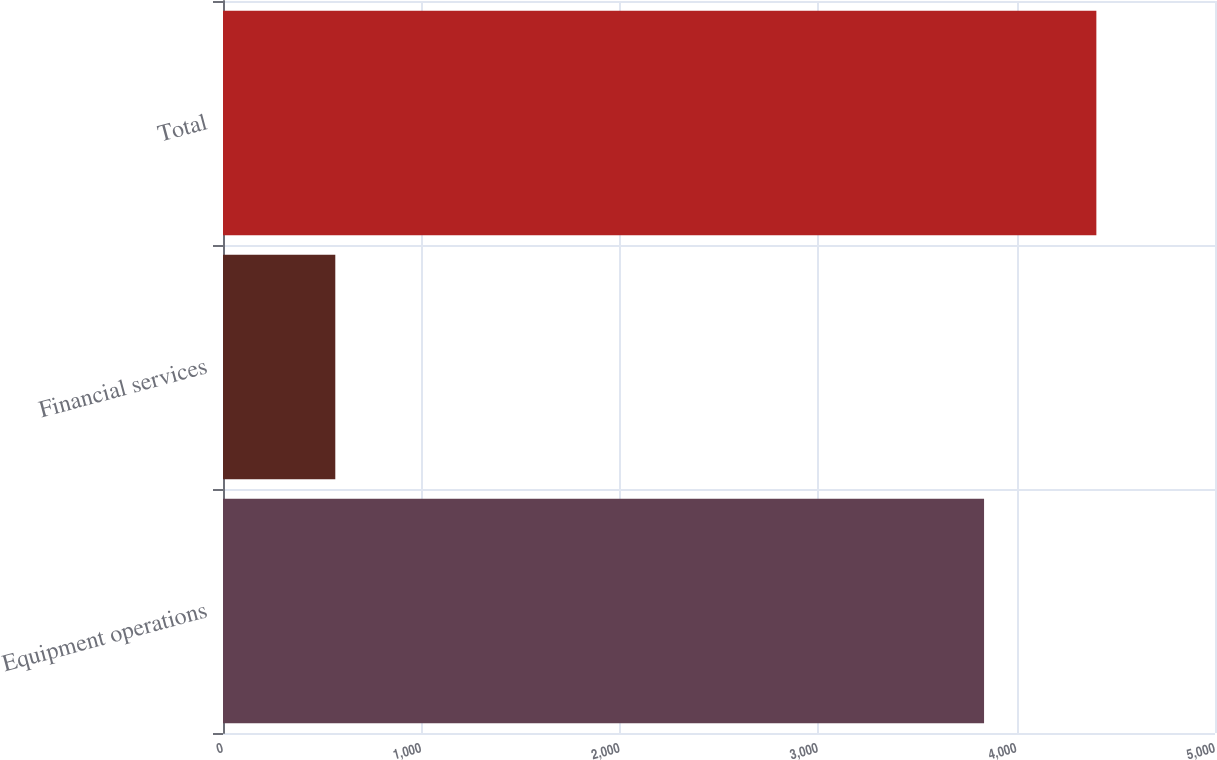Convert chart. <chart><loc_0><loc_0><loc_500><loc_500><bar_chart><fcel>Equipment operations<fcel>Financial services<fcel>Total<nl><fcel>3836<fcel>566<fcel>4402<nl></chart> 